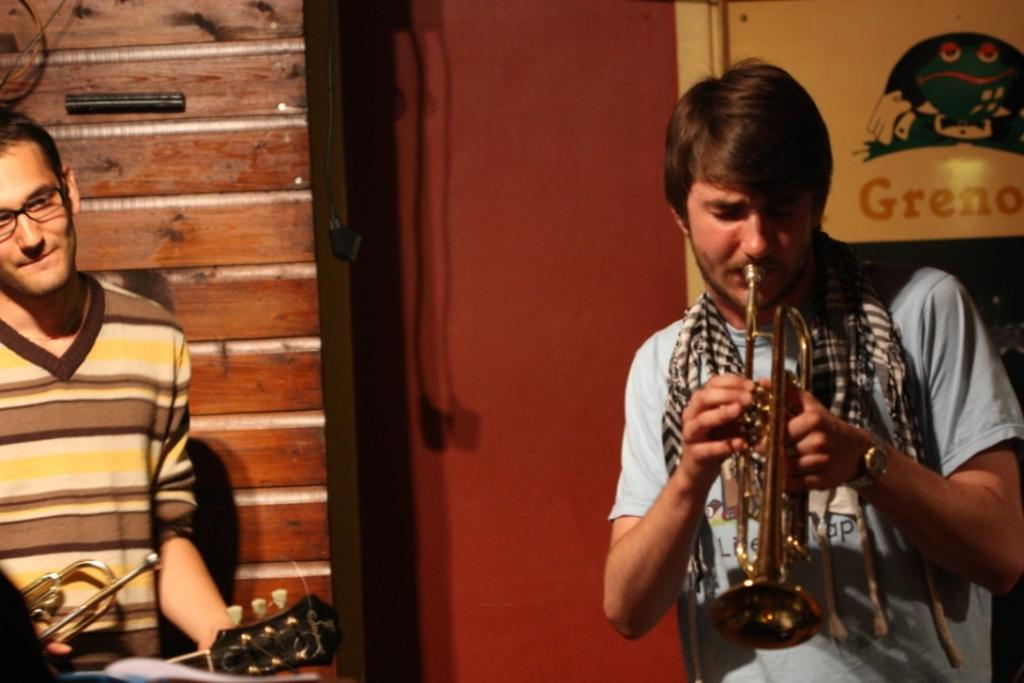How many people are in the image? There are two men in the image. What are the men doing in the image? The men are holding musical instruments. What can be seen in the background of the image? There is a door, a wall, and a board in the background of the image. What type of food is the worm eating in the image? There is no worm or food present in the image. 